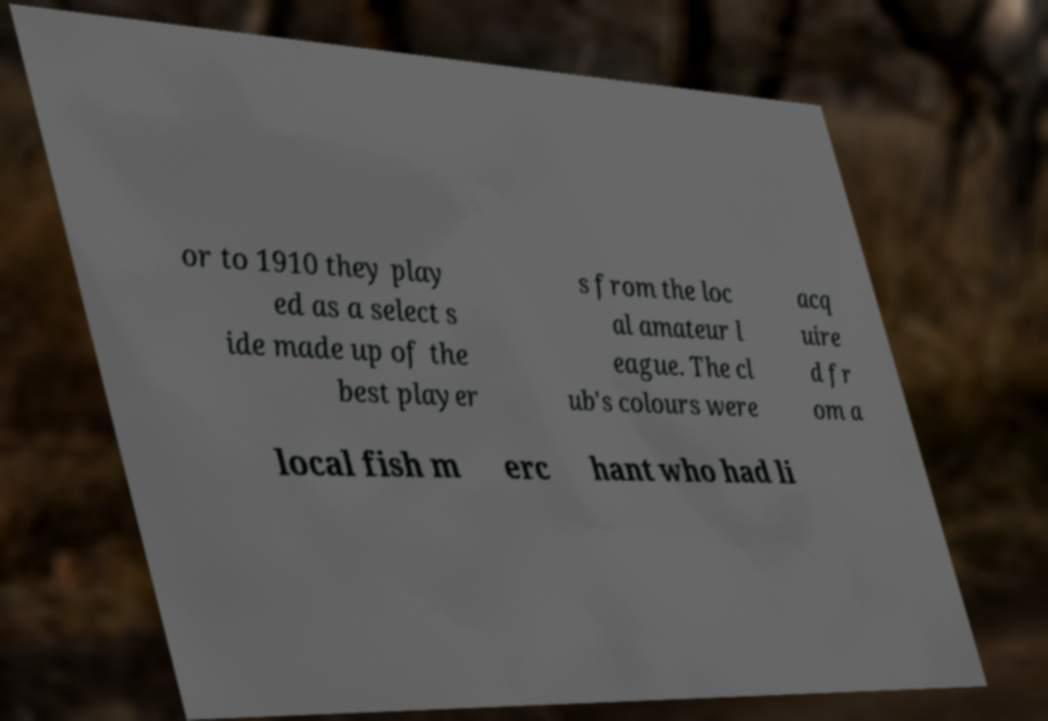Could you extract and type out the text from this image? or to 1910 they play ed as a select s ide made up of the best player s from the loc al amateur l eague. The cl ub's colours were acq uire d fr om a local fish m erc hant who had li 